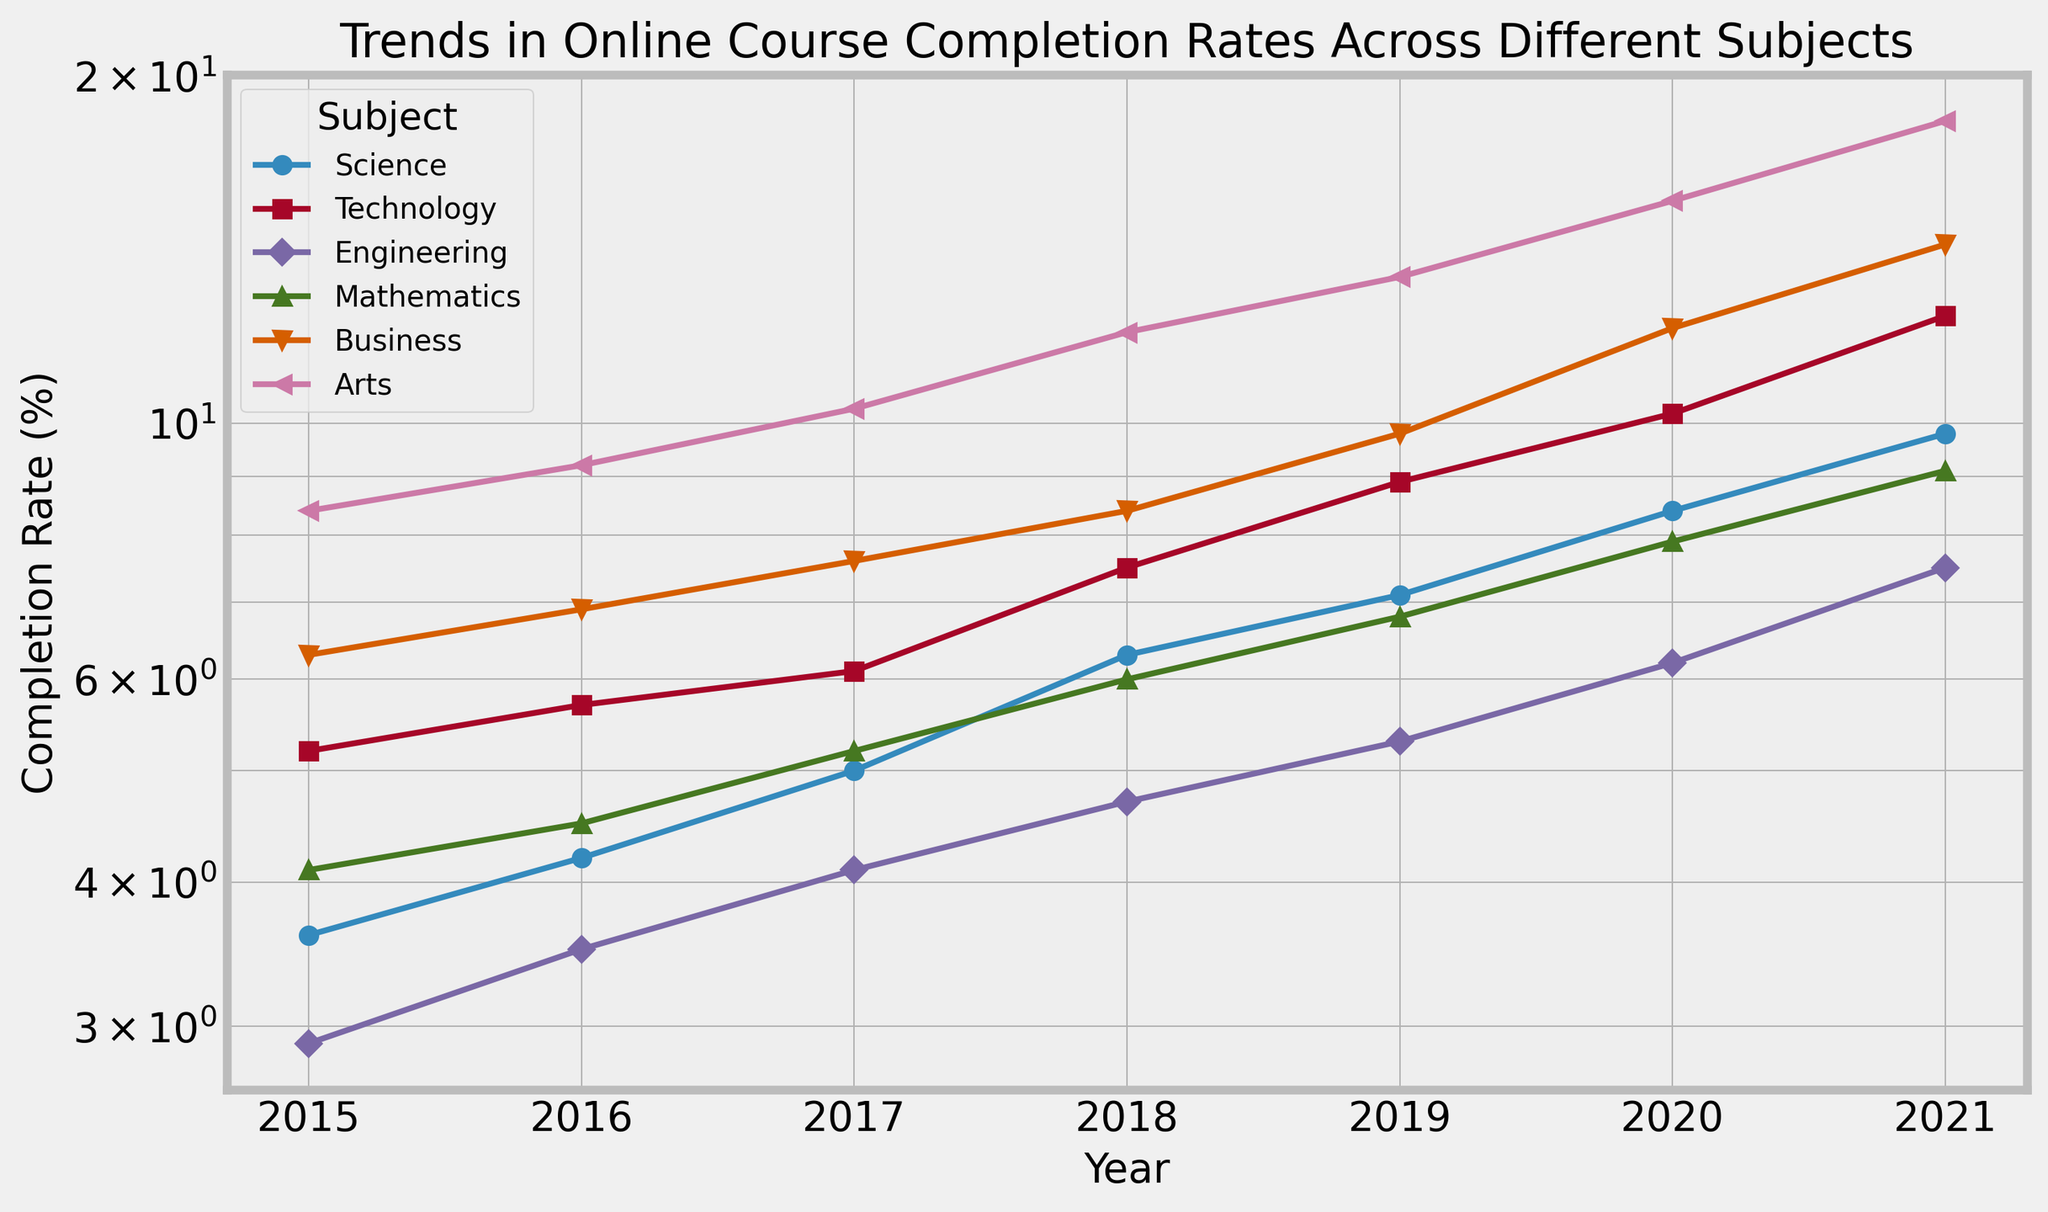Which subject had the highest online course completion rate in 2021? The figure shows different colored lines representing subjects. The highest point in 2021 on the log scale y-axis represents the subject with the highest completion rate. By looking at the graph, we see that Arts has the highest completion rate in 2021.
Answer: Arts How did the completion rate for Mathematics change from 2015 to 2021? On the figure, locate the line for Mathematics and compare the y-values for the years 2015 and 2021. The completion rate increased from 4.1% in 2015 to 9.1% in 2021.
Answer: Increased from 4.1% to 9.1% Which subject showed the most significant increase in completion rates from 2015 to 2021? To determine this, we need to look at the difference in the y-values from 2015 to 2021 for each subject. Arts shows the steepest increase from 8.4% in 2015 to 18.3% in 2021.
Answer: Arts Compare the completion rates of Science and Technology subjects in 2017. Which one is higher? In the figure, identify the points for Science and Technology in 2017. The completion rate for Science is 5.0%, while for Technology, it is 6.1%. Technology has a higher rate.
Answer: Technology What is the average completion rate for Engineering from 2018 to 2020? We need to calculate the average of the completion rates for Engineering in 2018, 2019, and 2020. The rates are 4.7%, 5.3%, and 6.2%. The average is (4.7 + 5.3 + 6.2) / 3 = 5.4%.
Answer: 5.4% What trend can be observed in the completion rates for Business from 2015 to 2021? The figure shows the line for Business steadily rising from 6.3% in 2015 to 14.3% in 2021. This indicates a consistent upward trend in completion rates.
Answer: Consistent upward trend Between which consecutive years did Technology see the largest increase in completion rate? Examine the line for Technology and compare the vertical distances (log scale) between consecutive years. The largest increase is between 2020 and 2021, from 10.2% to 12.4%.
Answer: 2020 and 2021 What's the completion rate difference between Science and Business subjects in 2020? Identify the points for Science and Business in 2020. The completion rates are 8.4% for Science and 12.1% for Business. Subtract the former from the latter: 12.1% - 8.4% = 3.7%.
Answer: 3.7% How did the completion rate for Arts change annually from 2015 to 2021? Observe the line for Arts in the figure and the annual increases. The rates are 8.4%, 9.2%, 10.3%, 12.0%, 13.4%, 15.6%, and 18.3%. The increases are relatively consistent, indicating a steady rise each year.
Answer: Steady annual rise Which subject consistently had the lowest completion rate, and what is the rate in 2021? By comparing the points on the log scale for each year, identify the subject with the lowest values throughout. Engineering consistently had the lowest rates, reaching 7.5% in 2021.
Answer: Engineering, 7.5% 